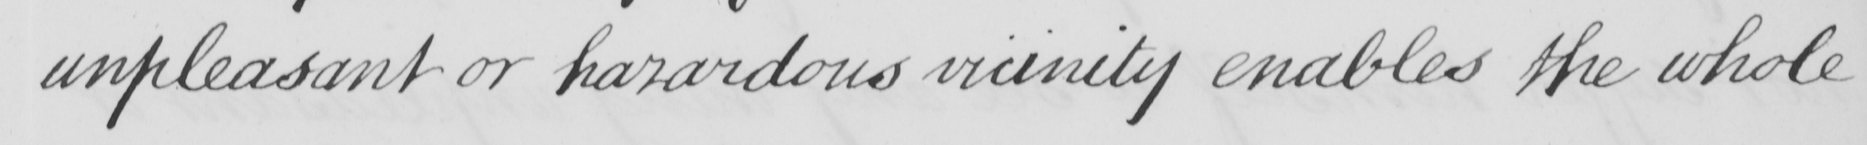Can you read and transcribe this handwriting? unpleasant or hazardous vicinity enables the whole 